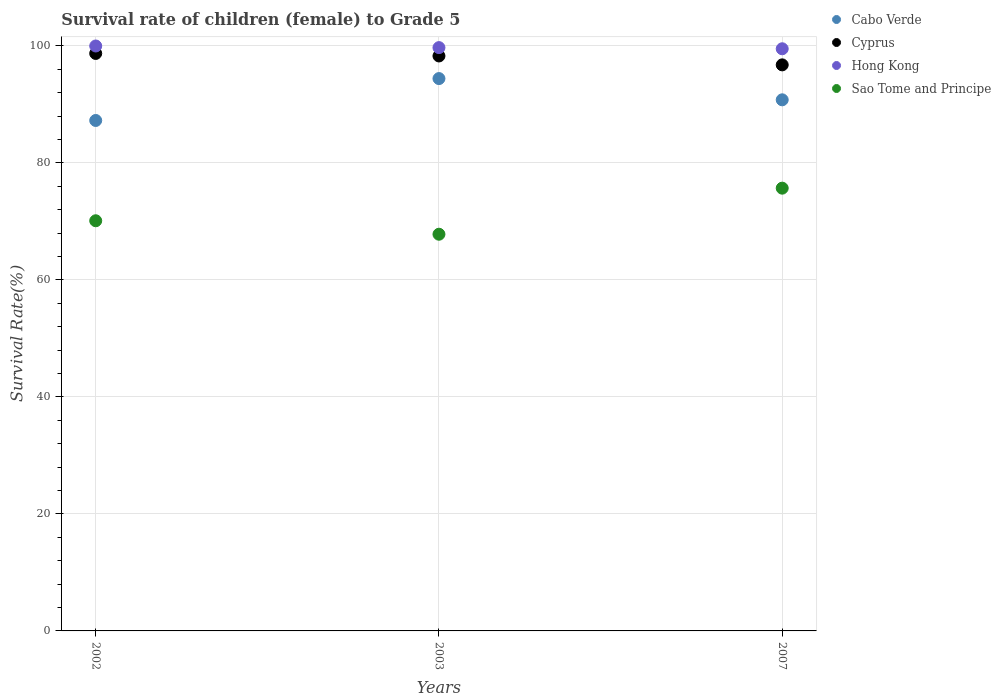How many different coloured dotlines are there?
Make the answer very short. 4. Is the number of dotlines equal to the number of legend labels?
Offer a terse response. Yes. What is the survival rate of female children to grade 5 in Sao Tome and Principe in 2007?
Your response must be concise. 75.69. Across all years, what is the maximum survival rate of female children to grade 5 in Sao Tome and Principe?
Keep it short and to the point. 75.69. Across all years, what is the minimum survival rate of female children to grade 5 in Cyprus?
Your answer should be very brief. 96.77. In which year was the survival rate of female children to grade 5 in Hong Kong maximum?
Your response must be concise. 2002. What is the total survival rate of female children to grade 5 in Cyprus in the graph?
Your answer should be very brief. 293.79. What is the difference between the survival rate of female children to grade 5 in Cyprus in 2003 and that in 2007?
Provide a succinct answer. 1.52. What is the difference between the survival rate of female children to grade 5 in Cyprus in 2002 and the survival rate of female children to grade 5 in Hong Kong in 2003?
Your response must be concise. -1. What is the average survival rate of female children to grade 5 in Cyprus per year?
Your answer should be very brief. 97.93. In the year 2003, what is the difference between the survival rate of female children to grade 5 in Cyprus and survival rate of female children to grade 5 in Hong Kong?
Your response must be concise. -1.43. What is the ratio of the survival rate of female children to grade 5 in Hong Kong in 2002 to that in 2007?
Provide a succinct answer. 1. What is the difference between the highest and the second highest survival rate of female children to grade 5 in Hong Kong?
Your response must be concise. 0.28. What is the difference between the highest and the lowest survival rate of female children to grade 5 in Hong Kong?
Offer a very short reply. 0.48. In how many years, is the survival rate of female children to grade 5 in Cyprus greater than the average survival rate of female children to grade 5 in Cyprus taken over all years?
Your response must be concise. 2. Is it the case that in every year, the sum of the survival rate of female children to grade 5 in Cabo Verde and survival rate of female children to grade 5 in Hong Kong  is greater than the survival rate of female children to grade 5 in Cyprus?
Ensure brevity in your answer.  Yes. Does the survival rate of female children to grade 5 in Hong Kong monotonically increase over the years?
Offer a terse response. No. Is the survival rate of female children to grade 5 in Cyprus strictly greater than the survival rate of female children to grade 5 in Hong Kong over the years?
Offer a very short reply. No. How many years are there in the graph?
Ensure brevity in your answer.  3. What is the difference between two consecutive major ticks on the Y-axis?
Your answer should be very brief. 20. Are the values on the major ticks of Y-axis written in scientific E-notation?
Your answer should be compact. No. Where does the legend appear in the graph?
Your response must be concise. Top right. How are the legend labels stacked?
Make the answer very short. Vertical. What is the title of the graph?
Ensure brevity in your answer.  Survival rate of children (female) to Grade 5. Does "Andorra" appear as one of the legend labels in the graph?
Offer a terse response. No. What is the label or title of the X-axis?
Give a very brief answer. Years. What is the label or title of the Y-axis?
Your answer should be very brief. Survival Rate(%). What is the Survival Rate(%) of Cabo Verde in 2002?
Give a very brief answer. 87.27. What is the Survival Rate(%) in Cyprus in 2002?
Your response must be concise. 98.72. What is the Survival Rate(%) in Sao Tome and Principe in 2002?
Provide a succinct answer. 70.12. What is the Survival Rate(%) in Cabo Verde in 2003?
Offer a very short reply. 94.43. What is the Survival Rate(%) in Cyprus in 2003?
Keep it short and to the point. 98.29. What is the Survival Rate(%) of Hong Kong in 2003?
Provide a succinct answer. 99.72. What is the Survival Rate(%) of Sao Tome and Principe in 2003?
Your answer should be very brief. 67.82. What is the Survival Rate(%) of Cabo Verde in 2007?
Make the answer very short. 90.8. What is the Survival Rate(%) of Cyprus in 2007?
Provide a short and direct response. 96.77. What is the Survival Rate(%) of Hong Kong in 2007?
Your response must be concise. 99.52. What is the Survival Rate(%) in Sao Tome and Principe in 2007?
Keep it short and to the point. 75.69. Across all years, what is the maximum Survival Rate(%) of Cabo Verde?
Provide a succinct answer. 94.43. Across all years, what is the maximum Survival Rate(%) in Cyprus?
Your answer should be very brief. 98.72. Across all years, what is the maximum Survival Rate(%) in Sao Tome and Principe?
Your answer should be compact. 75.69. Across all years, what is the minimum Survival Rate(%) in Cabo Verde?
Ensure brevity in your answer.  87.27. Across all years, what is the minimum Survival Rate(%) in Cyprus?
Make the answer very short. 96.77. Across all years, what is the minimum Survival Rate(%) in Hong Kong?
Make the answer very short. 99.52. Across all years, what is the minimum Survival Rate(%) of Sao Tome and Principe?
Your response must be concise. 67.82. What is the total Survival Rate(%) in Cabo Verde in the graph?
Your response must be concise. 272.49. What is the total Survival Rate(%) of Cyprus in the graph?
Your answer should be compact. 293.79. What is the total Survival Rate(%) in Hong Kong in the graph?
Make the answer very short. 299.24. What is the total Survival Rate(%) in Sao Tome and Principe in the graph?
Keep it short and to the point. 213.63. What is the difference between the Survival Rate(%) in Cabo Verde in 2002 and that in 2003?
Provide a short and direct response. -7.16. What is the difference between the Survival Rate(%) of Cyprus in 2002 and that in 2003?
Your response must be concise. 0.43. What is the difference between the Survival Rate(%) in Hong Kong in 2002 and that in 2003?
Make the answer very short. 0.28. What is the difference between the Survival Rate(%) of Sao Tome and Principe in 2002 and that in 2003?
Make the answer very short. 2.3. What is the difference between the Survival Rate(%) of Cabo Verde in 2002 and that in 2007?
Provide a short and direct response. -3.53. What is the difference between the Survival Rate(%) of Cyprus in 2002 and that in 2007?
Offer a very short reply. 1.95. What is the difference between the Survival Rate(%) of Hong Kong in 2002 and that in 2007?
Give a very brief answer. 0.48. What is the difference between the Survival Rate(%) of Sao Tome and Principe in 2002 and that in 2007?
Provide a succinct answer. -5.57. What is the difference between the Survival Rate(%) in Cabo Verde in 2003 and that in 2007?
Provide a succinct answer. 3.63. What is the difference between the Survival Rate(%) of Cyprus in 2003 and that in 2007?
Make the answer very short. 1.52. What is the difference between the Survival Rate(%) of Hong Kong in 2003 and that in 2007?
Provide a short and direct response. 0.2. What is the difference between the Survival Rate(%) in Sao Tome and Principe in 2003 and that in 2007?
Make the answer very short. -7.88. What is the difference between the Survival Rate(%) of Cabo Verde in 2002 and the Survival Rate(%) of Cyprus in 2003?
Provide a succinct answer. -11.03. What is the difference between the Survival Rate(%) of Cabo Verde in 2002 and the Survival Rate(%) of Hong Kong in 2003?
Ensure brevity in your answer.  -12.46. What is the difference between the Survival Rate(%) of Cabo Verde in 2002 and the Survival Rate(%) of Sao Tome and Principe in 2003?
Make the answer very short. 19.45. What is the difference between the Survival Rate(%) of Cyprus in 2002 and the Survival Rate(%) of Hong Kong in 2003?
Ensure brevity in your answer.  -1. What is the difference between the Survival Rate(%) in Cyprus in 2002 and the Survival Rate(%) in Sao Tome and Principe in 2003?
Offer a terse response. 30.91. What is the difference between the Survival Rate(%) of Hong Kong in 2002 and the Survival Rate(%) of Sao Tome and Principe in 2003?
Give a very brief answer. 32.18. What is the difference between the Survival Rate(%) of Cabo Verde in 2002 and the Survival Rate(%) of Cyprus in 2007?
Provide a succinct answer. -9.51. What is the difference between the Survival Rate(%) of Cabo Verde in 2002 and the Survival Rate(%) of Hong Kong in 2007?
Keep it short and to the point. -12.26. What is the difference between the Survival Rate(%) of Cabo Verde in 2002 and the Survival Rate(%) of Sao Tome and Principe in 2007?
Your answer should be very brief. 11.57. What is the difference between the Survival Rate(%) of Cyprus in 2002 and the Survival Rate(%) of Hong Kong in 2007?
Keep it short and to the point. -0.8. What is the difference between the Survival Rate(%) of Cyprus in 2002 and the Survival Rate(%) of Sao Tome and Principe in 2007?
Your answer should be compact. 23.03. What is the difference between the Survival Rate(%) in Hong Kong in 2002 and the Survival Rate(%) in Sao Tome and Principe in 2007?
Your answer should be very brief. 24.31. What is the difference between the Survival Rate(%) in Cabo Verde in 2003 and the Survival Rate(%) in Cyprus in 2007?
Make the answer very short. -2.34. What is the difference between the Survival Rate(%) in Cabo Verde in 2003 and the Survival Rate(%) in Hong Kong in 2007?
Make the answer very short. -5.09. What is the difference between the Survival Rate(%) of Cabo Verde in 2003 and the Survival Rate(%) of Sao Tome and Principe in 2007?
Offer a very short reply. 18.73. What is the difference between the Survival Rate(%) in Cyprus in 2003 and the Survival Rate(%) in Hong Kong in 2007?
Ensure brevity in your answer.  -1.23. What is the difference between the Survival Rate(%) in Cyprus in 2003 and the Survival Rate(%) in Sao Tome and Principe in 2007?
Make the answer very short. 22.6. What is the difference between the Survival Rate(%) in Hong Kong in 2003 and the Survival Rate(%) in Sao Tome and Principe in 2007?
Offer a very short reply. 24.03. What is the average Survival Rate(%) of Cabo Verde per year?
Your response must be concise. 90.83. What is the average Survival Rate(%) of Cyprus per year?
Provide a short and direct response. 97.93. What is the average Survival Rate(%) in Hong Kong per year?
Make the answer very short. 99.75. What is the average Survival Rate(%) in Sao Tome and Principe per year?
Provide a succinct answer. 71.21. In the year 2002, what is the difference between the Survival Rate(%) in Cabo Verde and Survival Rate(%) in Cyprus?
Your answer should be compact. -11.46. In the year 2002, what is the difference between the Survival Rate(%) of Cabo Verde and Survival Rate(%) of Hong Kong?
Provide a succinct answer. -12.73. In the year 2002, what is the difference between the Survival Rate(%) in Cabo Verde and Survival Rate(%) in Sao Tome and Principe?
Your answer should be very brief. 17.14. In the year 2002, what is the difference between the Survival Rate(%) in Cyprus and Survival Rate(%) in Hong Kong?
Provide a succinct answer. -1.28. In the year 2002, what is the difference between the Survival Rate(%) of Cyprus and Survival Rate(%) of Sao Tome and Principe?
Keep it short and to the point. 28.6. In the year 2002, what is the difference between the Survival Rate(%) in Hong Kong and Survival Rate(%) in Sao Tome and Principe?
Ensure brevity in your answer.  29.88. In the year 2003, what is the difference between the Survival Rate(%) of Cabo Verde and Survival Rate(%) of Cyprus?
Keep it short and to the point. -3.87. In the year 2003, what is the difference between the Survival Rate(%) in Cabo Verde and Survival Rate(%) in Hong Kong?
Your answer should be compact. -5.29. In the year 2003, what is the difference between the Survival Rate(%) of Cabo Verde and Survival Rate(%) of Sao Tome and Principe?
Your answer should be compact. 26.61. In the year 2003, what is the difference between the Survival Rate(%) in Cyprus and Survival Rate(%) in Hong Kong?
Make the answer very short. -1.43. In the year 2003, what is the difference between the Survival Rate(%) in Cyprus and Survival Rate(%) in Sao Tome and Principe?
Offer a terse response. 30.48. In the year 2003, what is the difference between the Survival Rate(%) in Hong Kong and Survival Rate(%) in Sao Tome and Principe?
Ensure brevity in your answer.  31.9. In the year 2007, what is the difference between the Survival Rate(%) of Cabo Verde and Survival Rate(%) of Cyprus?
Make the answer very short. -5.97. In the year 2007, what is the difference between the Survival Rate(%) of Cabo Verde and Survival Rate(%) of Hong Kong?
Provide a short and direct response. -8.73. In the year 2007, what is the difference between the Survival Rate(%) in Cabo Verde and Survival Rate(%) in Sao Tome and Principe?
Ensure brevity in your answer.  15.1. In the year 2007, what is the difference between the Survival Rate(%) in Cyprus and Survival Rate(%) in Hong Kong?
Make the answer very short. -2.75. In the year 2007, what is the difference between the Survival Rate(%) in Cyprus and Survival Rate(%) in Sao Tome and Principe?
Make the answer very short. 21.08. In the year 2007, what is the difference between the Survival Rate(%) in Hong Kong and Survival Rate(%) in Sao Tome and Principe?
Provide a short and direct response. 23.83. What is the ratio of the Survival Rate(%) of Cabo Verde in 2002 to that in 2003?
Your response must be concise. 0.92. What is the ratio of the Survival Rate(%) of Hong Kong in 2002 to that in 2003?
Provide a succinct answer. 1. What is the ratio of the Survival Rate(%) in Sao Tome and Principe in 2002 to that in 2003?
Provide a short and direct response. 1.03. What is the ratio of the Survival Rate(%) of Cabo Verde in 2002 to that in 2007?
Make the answer very short. 0.96. What is the ratio of the Survival Rate(%) in Cyprus in 2002 to that in 2007?
Make the answer very short. 1.02. What is the ratio of the Survival Rate(%) of Sao Tome and Principe in 2002 to that in 2007?
Your response must be concise. 0.93. What is the ratio of the Survival Rate(%) in Cyprus in 2003 to that in 2007?
Your answer should be compact. 1.02. What is the ratio of the Survival Rate(%) in Hong Kong in 2003 to that in 2007?
Your answer should be compact. 1. What is the ratio of the Survival Rate(%) in Sao Tome and Principe in 2003 to that in 2007?
Offer a very short reply. 0.9. What is the difference between the highest and the second highest Survival Rate(%) in Cabo Verde?
Your response must be concise. 3.63. What is the difference between the highest and the second highest Survival Rate(%) in Cyprus?
Provide a succinct answer. 0.43. What is the difference between the highest and the second highest Survival Rate(%) in Hong Kong?
Your response must be concise. 0.28. What is the difference between the highest and the second highest Survival Rate(%) in Sao Tome and Principe?
Your response must be concise. 5.57. What is the difference between the highest and the lowest Survival Rate(%) of Cabo Verde?
Offer a terse response. 7.16. What is the difference between the highest and the lowest Survival Rate(%) of Cyprus?
Your answer should be very brief. 1.95. What is the difference between the highest and the lowest Survival Rate(%) of Hong Kong?
Provide a succinct answer. 0.48. What is the difference between the highest and the lowest Survival Rate(%) of Sao Tome and Principe?
Keep it short and to the point. 7.88. 